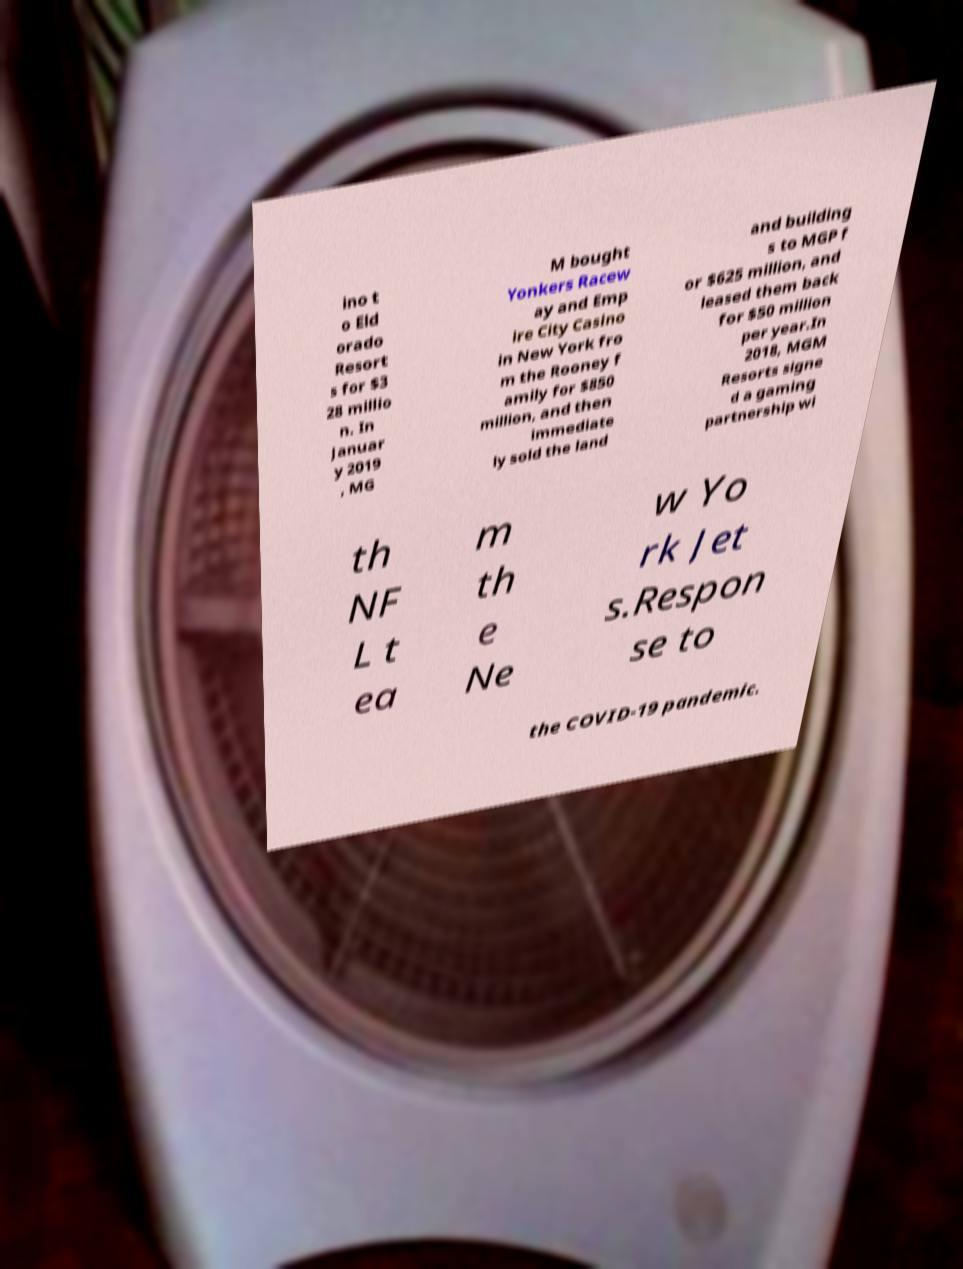For documentation purposes, I need the text within this image transcribed. Could you provide that? ino t o Eld orado Resort s for $3 28 millio n. In Januar y 2019 , MG M bought Yonkers Racew ay and Emp ire City Casino in New York fro m the Rooney f amily for $850 million, and then immediate ly sold the land and building s to MGP f or $625 million, and leased them back for $50 million per year.In 2018, MGM Resorts signe d a gaming partnership wi th NF L t ea m th e Ne w Yo rk Jet s.Respon se to the COVID-19 pandemic. 